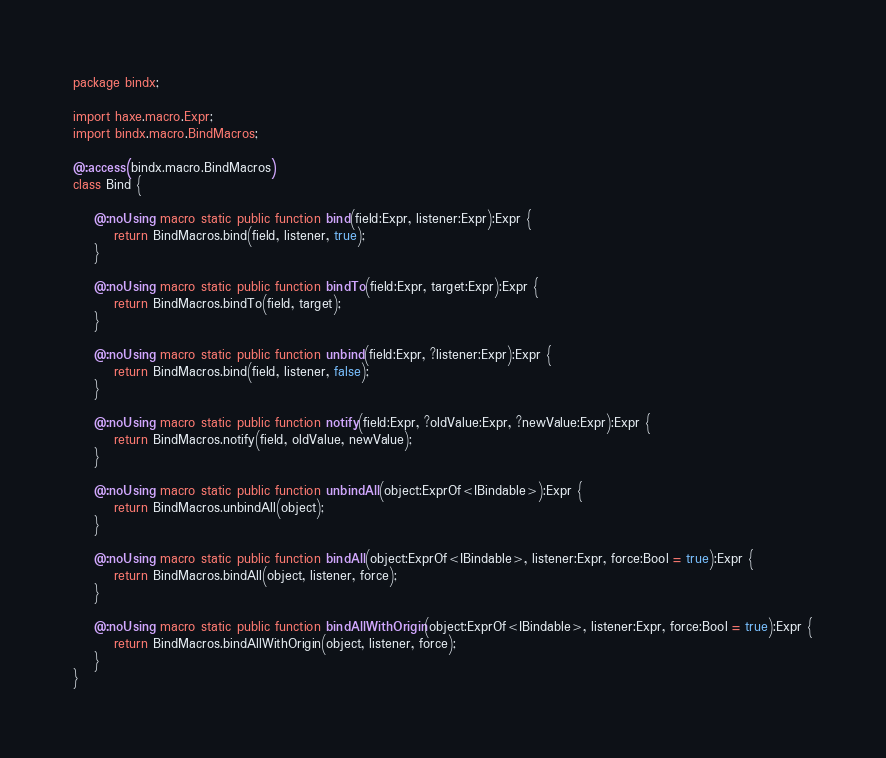<code> <loc_0><loc_0><loc_500><loc_500><_Haxe_>package bindx;

import haxe.macro.Expr;
import bindx.macro.BindMacros;

@:access(bindx.macro.BindMacros)
class Bind {

	@:noUsing macro static public function bind(field:Expr, listener:Expr):Expr {
		return BindMacros.bind(field, listener, true);
	}

	@:noUsing macro static public function bindTo(field:Expr, target:Expr):Expr {
		return BindMacros.bindTo(field, target);
	}

	@:noUsing macro static public function unbind(field:Expr, ?listener:Expr):Expr {
		return BindMacros.bind(field, listener, false);
	}

	@:noUsing macro static public function notify(field:Expr, ?oldValue:Expr, ?newValue:Expr):Expr {
		return BindMacros.notify(field, oldValue, newValue);
	}
    
    @:noUsing macro static public function unbindAll(object:ExprOf<IBindable>):Expr {
        return BindMacros.unbindAll(object);
    }

	@:noUsing macro static public function bindAll(object:ExprOf<IBindable>, listener:Expr, force:Bool = true):Expr {
		return BindMacros.bindAll(object, listener, force);
	}

	@:noUsing macro static public function bindAllWithOrigin(object:ExprOf<IBindable>, listener:Expr, force:Bool = true):Expr {
		return BindMacros.bindAllWithOrigin(object, listener, force);
	}
}</code> 